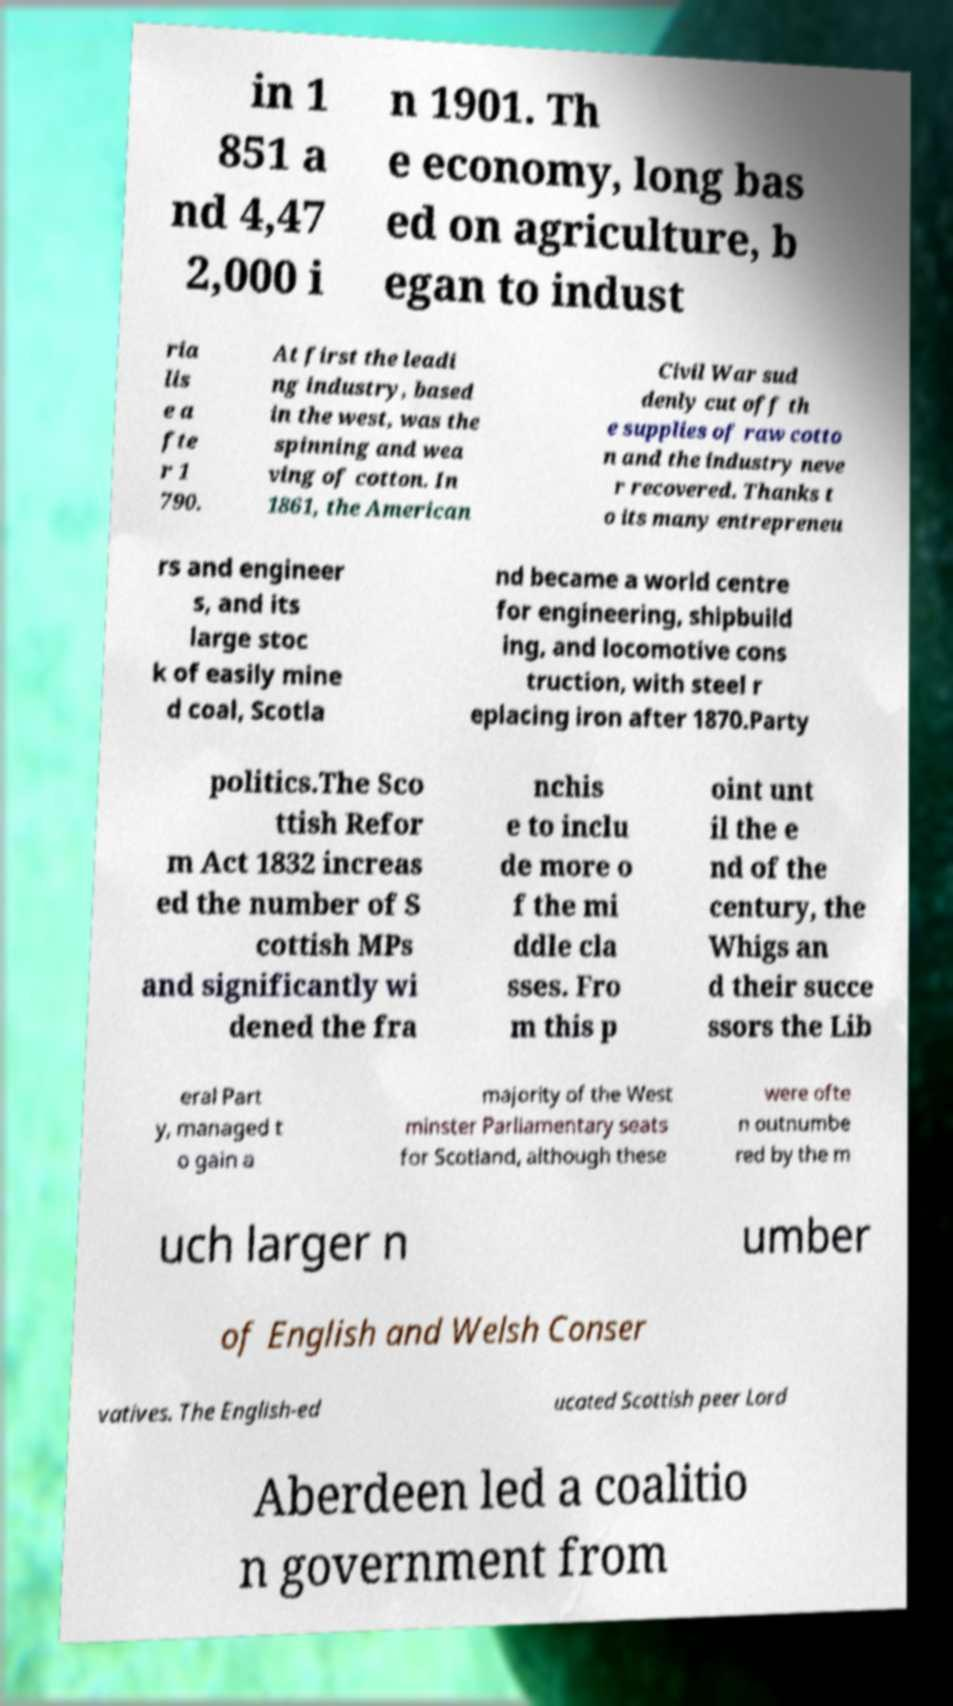What messages or text are displayed in this image? I need them in a readable, typed format. in 1 851 a nd 4,47 2,000 i n 1901. Th e economy, long bas ed on agriculture, b egan to indust ria lis e a fte r 1 790. At first the leadi ng industry, based in the west, was the spinning and wea ving of cotton. In 1861, the American Civil War sud denly cut off th e supplies of raw cotto n and the industry neve r recovered. Thanks t o its many entrepreneu rs and engineer s, and its large stoc k of easily mine d coal, Scotla nd became a world centre for engineering, shipbuild ing, and locomotive cons truction, with steel r eplacing iron after 1870.Party politics.The Sco ttish Refor m Act 1832 increas ed the number of S cottish MPs and significantly wi dened the fra nchis e to inclu de more o f the mi ddle cla sses. Fro m this p oint unt il the e nd of the century, the Whigs an d their succe ssors the Lib eral Part y, managed t o gain a majority of the West minster Parliamentary seats for Scotland, although these were ofte n outnumbe red by the m uch larger n umber of English and Welsh Conser vatives. The English-ed ucated Scottish peer Lord Aberdeen led a coalitio n government from 